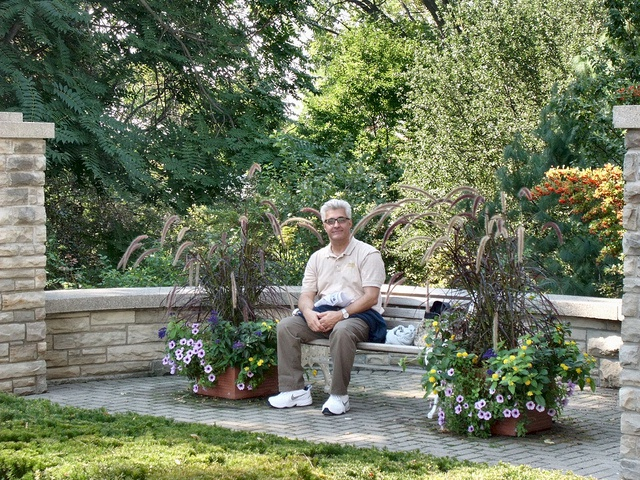Describe the objects in this image and their specific colors. I can see potted plant in black, gray, darkgray, and darkgreen tones, potted plant in black, gray, darkgreen, and darkgray tones, people in black, lightgray, gray, and darkgray tones, potted plant in black, olive, and darkgreen tones, and bench in black, darkgray, gray, and lightgray tones in this image. 